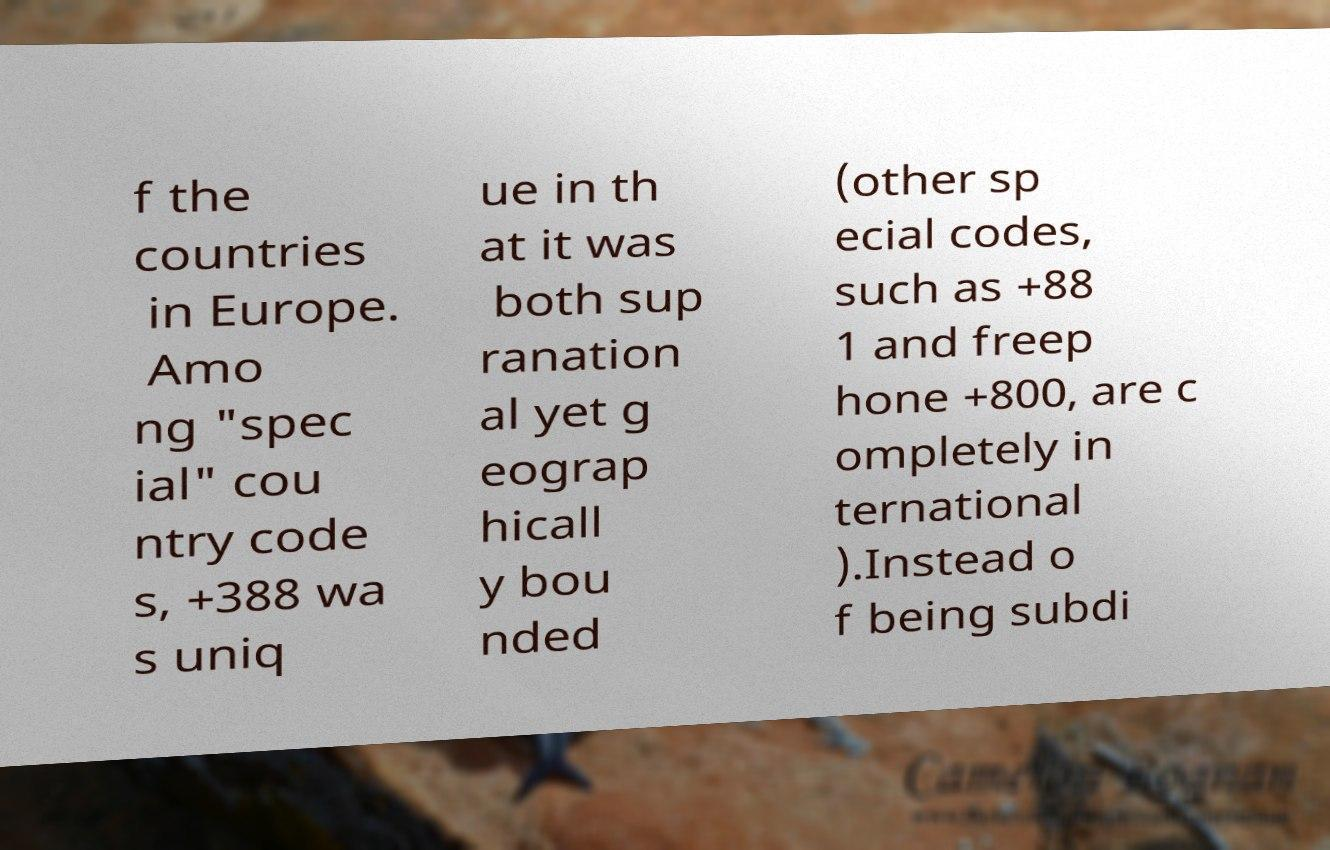Can you accurately transcribe the text from the provided image for me? f the countries in Europe. Amo ng "spec ial" cou ntry code s, +388 wa s uniq ue in th at it was both sup ranation al yet g eograp hicall y bou nded (other sp ecial codes, such as +88 1 and freep hone +800, are c ompletely in ternational ).Instead o f being subdi 